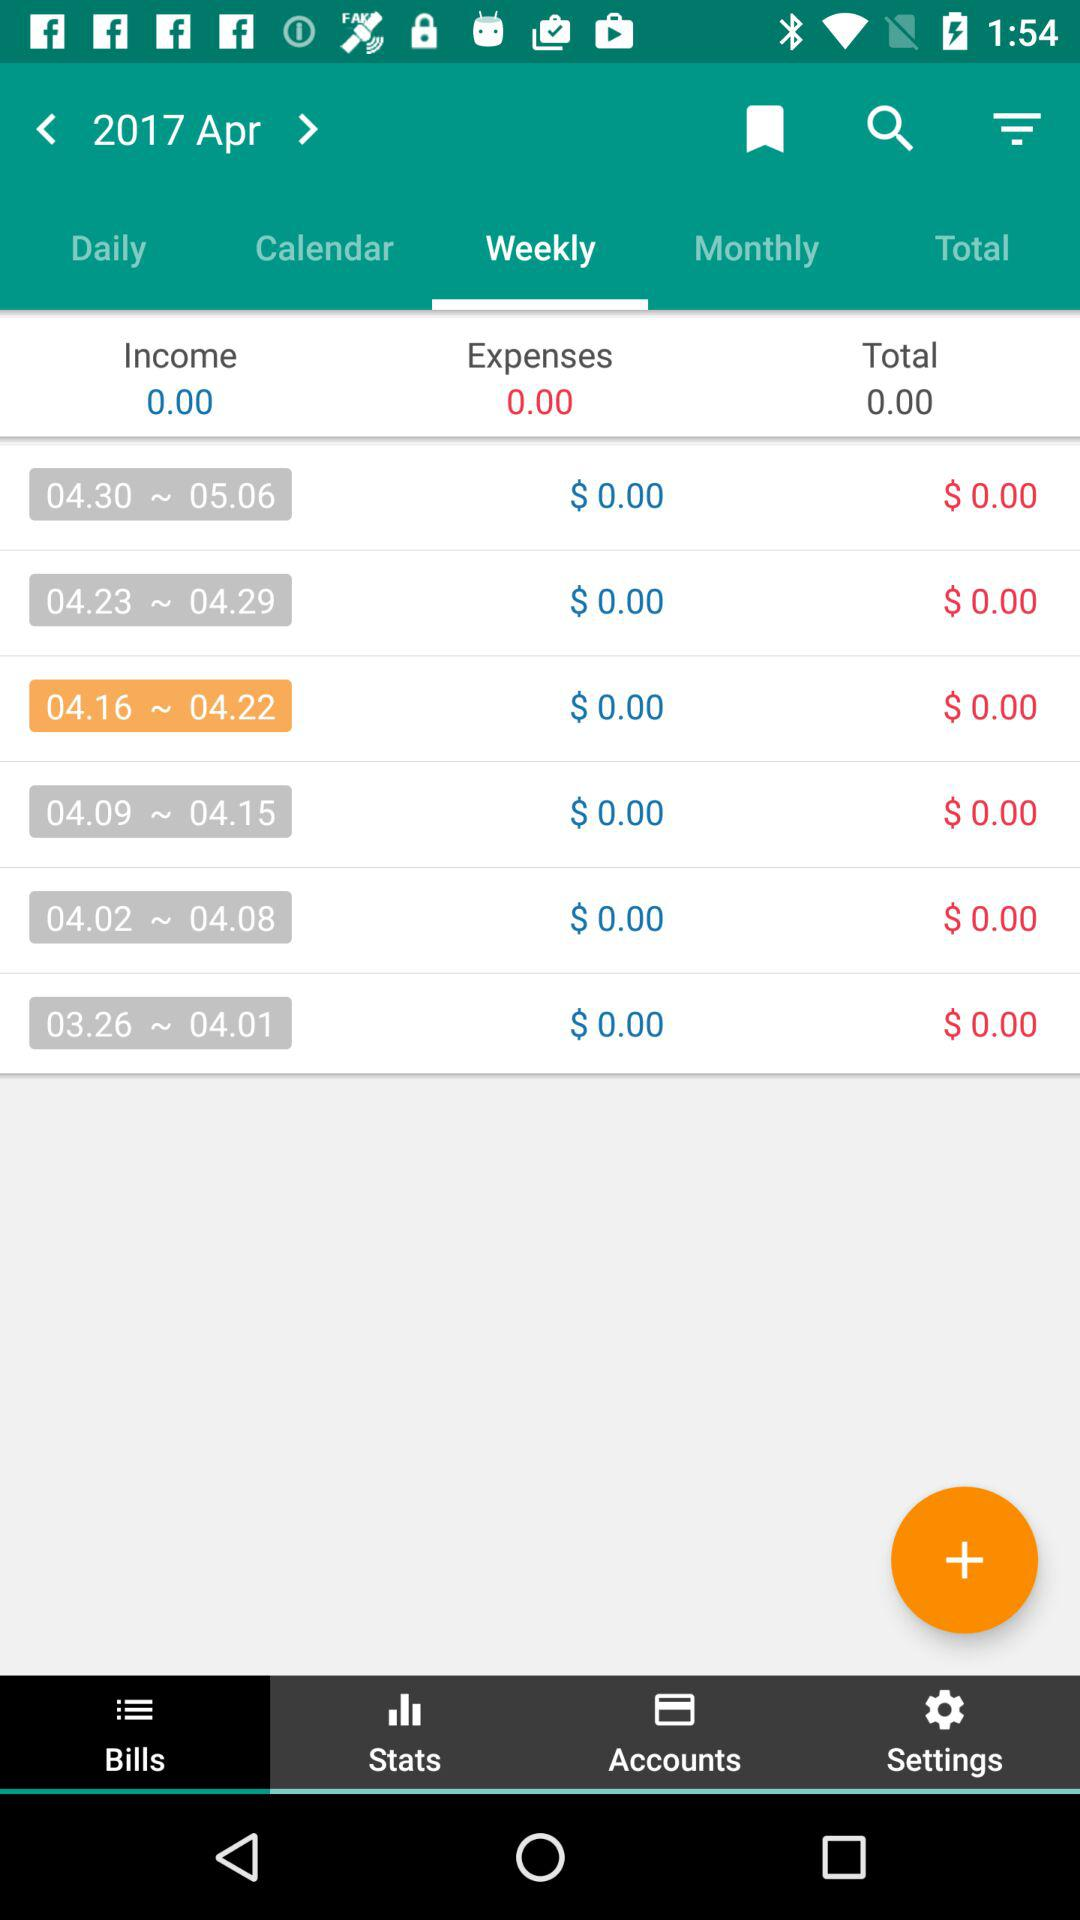What is the month and year? The month and year are April 2017. 